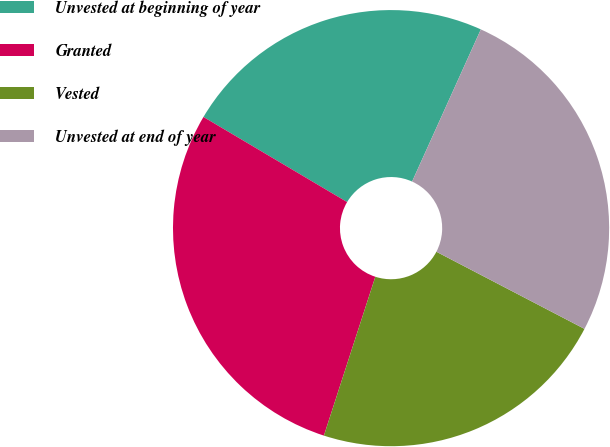Convert chart to OTSL. <chart><loc_0><loc_0><loc_500><loc_500><pie_chart><fcel>Unvested at beginning of year<fcel>Granted<fcel>Vested<fcel>Unvested at end of year<nl><fcel>23.24%<fcel>28.53%<fcel>22.34%<fcel>25.89%<nl></chart> 